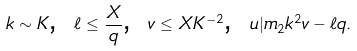<formula> <loc_0><loc_0><loc_500><loc_500>k \sim K \text {, } \ell \leq \frac { X } { q } \text {, } v \leq X K ^ { - 2 } \text {, } u | m _ { 2 } k ^ { 2 } v - \ell q .</formula> 